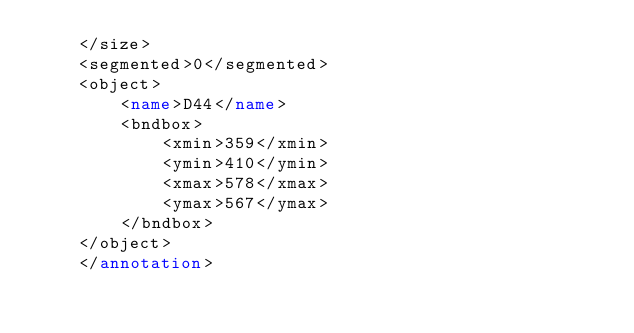<code> <loc_0><loc_0><loc_500><loc_500><_XML_>    </size>
    <segmented>0</segmented>
    <object>
        <name>D44</name>
        <bndbox>
            <xmin>359</xmin>
            <ymin>410</ymin>
            <xmax>578</xmax>
            <ymax>567</ymax>
        </bndbox>
    </object>
    </annotation></code> 